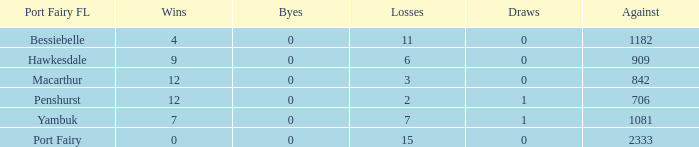How many byes when the draws are less than 0? 0.0. Help me parse the entirety of this table. {'header': ['Port Fairy FL', 'Wins', 'Byes', 'Losses', 'Draws', 'Against'], 'rows': [['Bessiebelle', '4', '0', '11', '0', '1182'], ['Hawkesdale', '9', '0', '6', '0', '909'], ['Macarthur', '12', '0', '3', '0', '842'], ['Penshurst', '12', '0', '2', '1', '706'], ['Yambuk', '7', '0', '7', '1', '1081'], ['Port Fairy', '0', '0', '15', '0', '2333']]} 